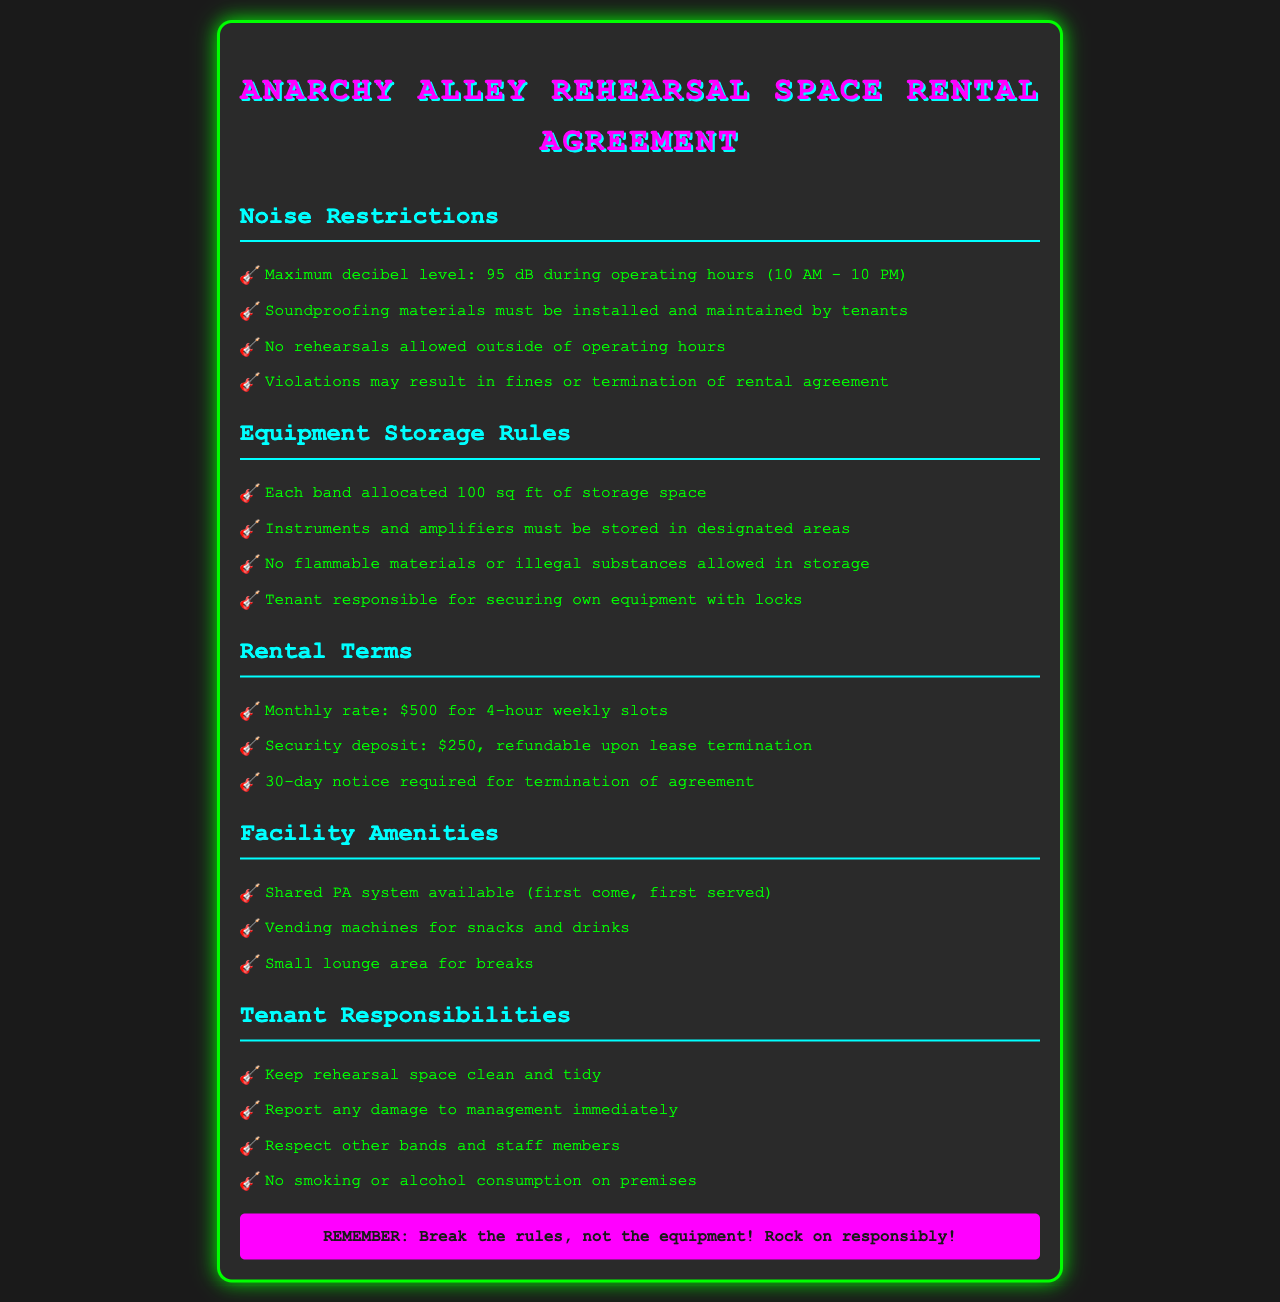What is the maximum allowed decibel level? The document states that the maximum decibel level during operating hours is 95 dB.
Answer: 95 dB What time are rehearsals allowed? The document specifies that no rehearsals are allowed outside of operating hours, which are from 10 AM to 10 PM.
Answer: 10 AM to 10 PM What is the security deposit amount? The document states that the security deposit is $250, refundable upon lease termination.
Answer: $250 How much space is allocated for each band? Each band is allocated 100 sq ft of storage space, as mentioned in the equipment storage rules.
Answer: 100 sq ft What is the monthly rental rate? The monthly rate for renting the rehearsal space, as indicated in the rental terms, is $500.
Answer: $500 What happens if noise violations occur? The document specifies that violations may result in fines or termination of the rental agreement.
Answer: Fines or termination What is the required notice period for terminating the agreement? The document states that a 30-day notice is required for the termination of the agreement.
Answer: 30 days What must tenants secure their equipment with? The document indicates that tenants are responsible for securing their own equipment with locks.
Answer: Locks What is prohibited in storage areas? The document lists that no flammable materials or illegal substances are allowed in storage.
Answer: Flammable materials or illegal substances 